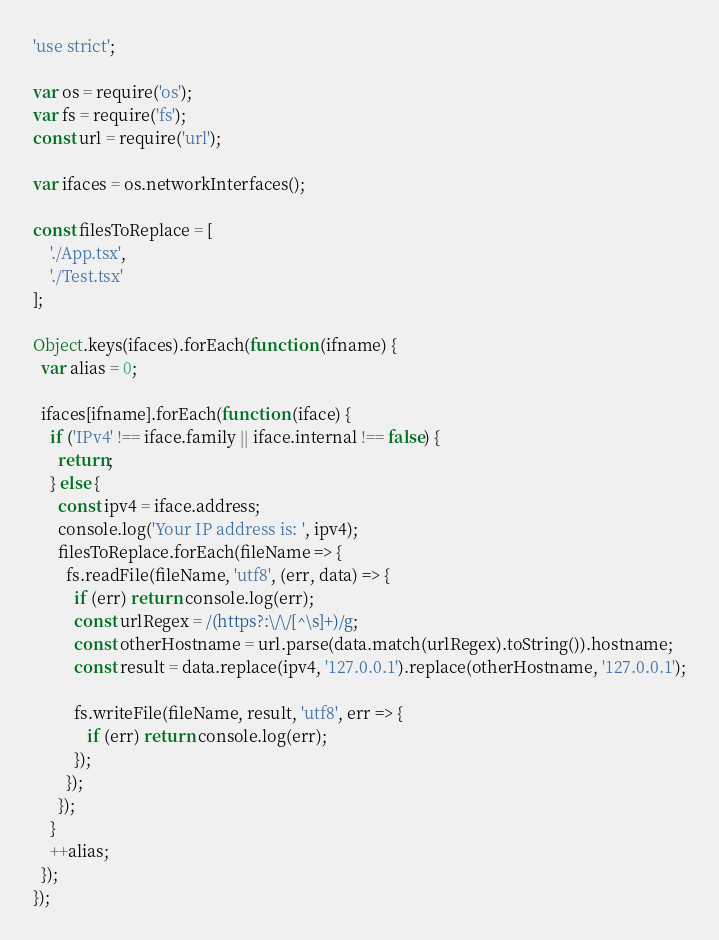<code> <loc_0><loc_0><loc_500><loc_500><_JavaScript_>'use strict';

var os = require('os');
var fs = require('fs');
const url = require('url');

var ifaces = os.networkInterfaces();

const filesToReplace = [
    './App.tsx',
    './Test.tsx'
];

Object.keys(ifaces).forEach(function (ifname) {
  var alias = 0;

  ifaces[ifname].forEach(function (iface) {
    if ('IPv4' !== iface.family || iface.internal !== false) {
      return;
    } else {
      const ipv4 = iface.address;
      console.log('Your IP address is: ', ipv4);
      filesToReplace.forEach(fileName => {
        fs.readFile(fileName, 'utf8', (err, data) => {
          if (err) return console.log(err);
          const urlRegex = /(https?:\/\/[^\s]+)/g;
          const otherHostname = url.parse(data.match(urlRegex).toString()).hostname;
          const result = data.replace(ipv4, '127.0.0.1').replace(otherHostname, '127.0.0.1');
        
          fs.writeFile(fileName, result, 'utf8', err => {
             if (err) return console.log(err);
          });
        });
      });
    }
    ++alias;
  });
});
</code> 